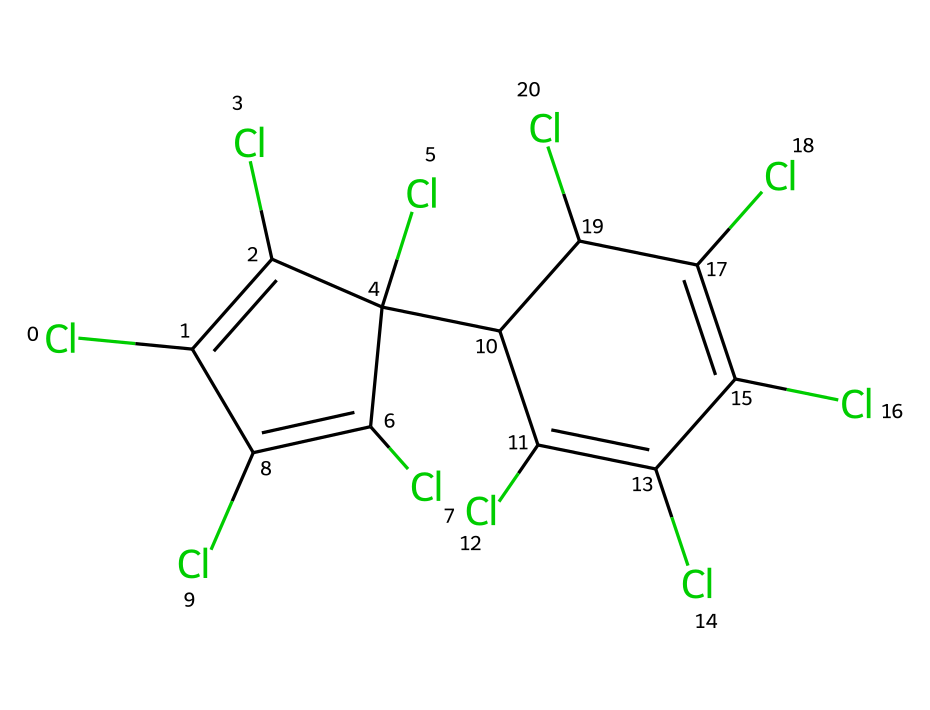What is the total number of chlorine atoms in this chemical? Analyzing the SMILES representation reveals that there are multiple 'Cl' notations. Counting each 'Cl' yields a total of 10 chlorine atoms present in the structure.
Answer: 10 How many carbon atoms does this chemical have? By interpreting the SMILES notation, we can identify the number of 'C' characters, which represent carbon atoms. There are 12 carbon atoms indicated in the structure.
Answer: 12 What type of pesticide does this structure represent? The presence of multiple chlorine atoms attached to carbons in a cyclic structure suggests that this compound is an organochlorine pesticide, known for its stability and persistence in the environment.
Answer: organochlorine What are the predominant elements in this pesticide? The structure contains a high number of chlorine atoms alongside carbon, which are the primary elements observed in the identified chemical. Counting them, we see chlorine and carbon are the two most significant elements.
Answer: chlorine, carbon How many double bonds are present in the chemical structure? Observing the SMILES representation, we analyze the placement of '=' symbols that denote double bonds between the carbon atoms. In this case, there are 5 instances of double bonds present in the structure.
Answer: 5 What might be a potential concern regarding the use of this pesticide? Organochlorine pesticides, such as this one, are known for their environmental persistence and potential to bioaccumulate, which can lead to health risks for humans and wildlife.
Answer: bioaccumulation Is this chemical likely to be soluble in water? The high chlorine content in conjunction with the structured carbon backbone typically suggests low water solubility due to hydrophobic characteristics of organochlorines, making it less soluble in polar solvents like water.
Answer: low 